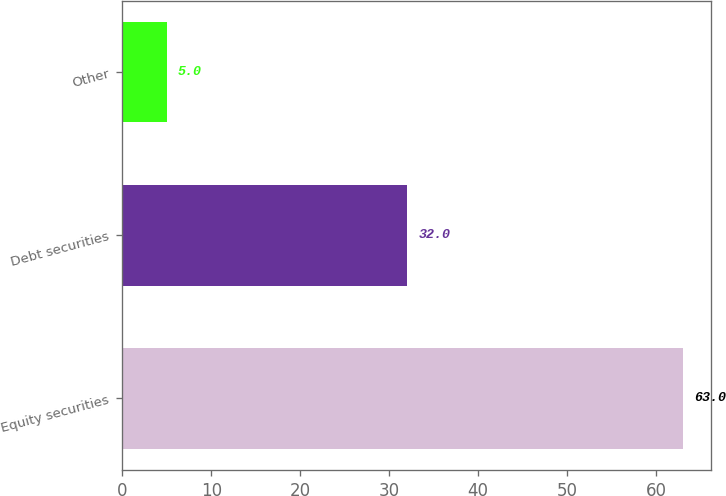<chart> <loc_0><loc_0><loc_500><loc_500><bar_chart><fcel>Equity securities<fcel>Debt securities<fcel>Other<nl><fcel>63<fcel>32<fcel>5<nl></chart> 